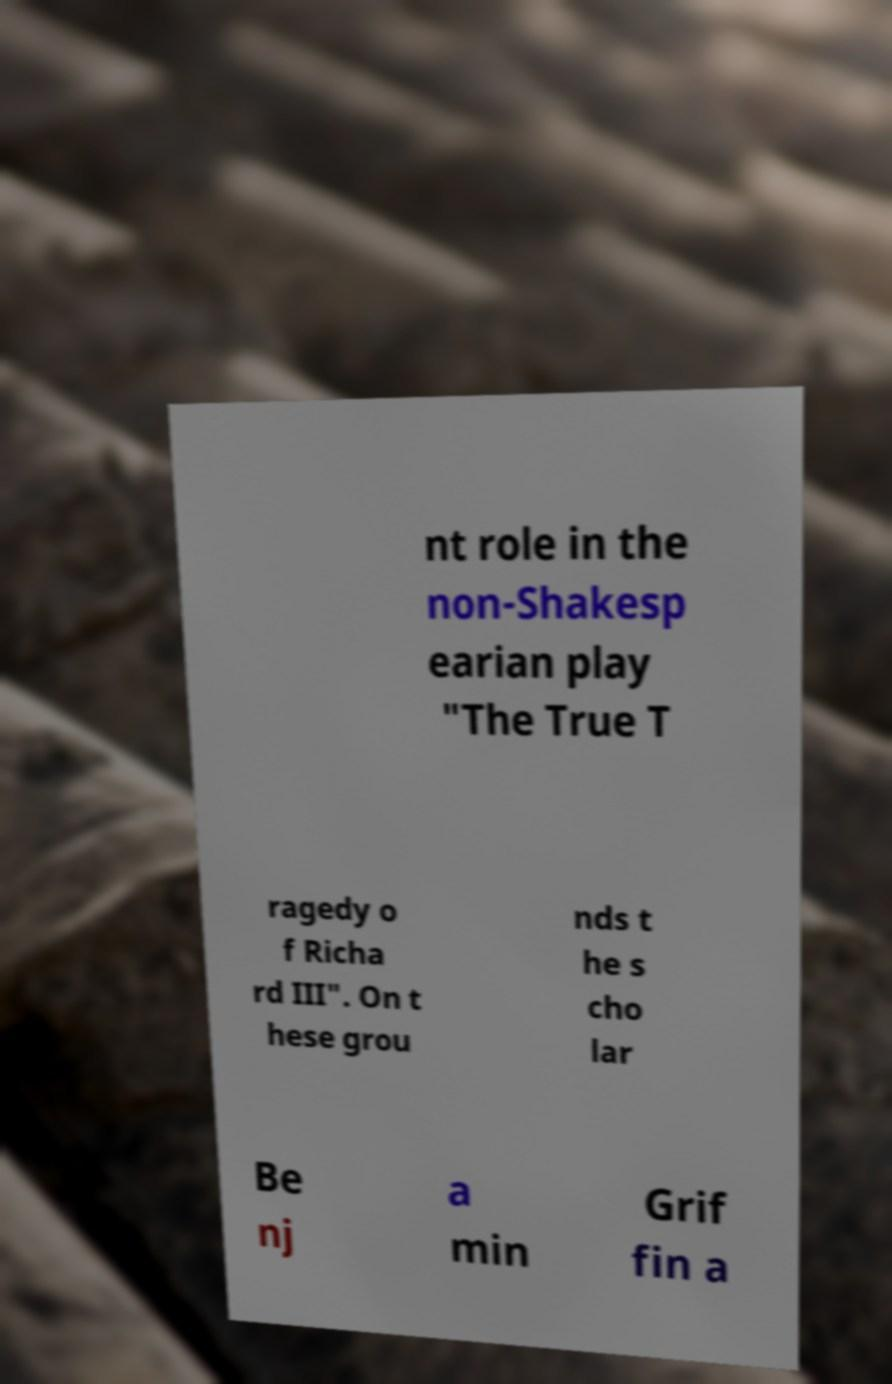I need the written content from this picture converted into text. Can you do that? nt role in the non-Shakesp earian play "The True T ragedy o f Richa rd III". On t hese grou nds t he s cho lar Be nj a min Grif fin a 